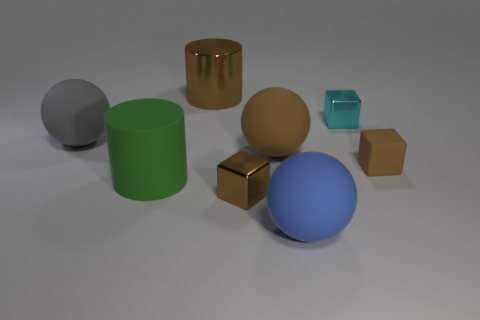There is a large brown matte object; does it have the same shape as the shiny object behind the cyan block?
Your answer should be compact. No. How many things are big brown rubber balls behind the green cylinder or matte objects in front of the big gray thing?
Ensure brevity in your answer.  4. What shape is the large object that is the same color as the metal cylinder?
Your answer should be compact. Sphere. There is a brown matte thing that is to the left of the tiny cyan shiny thing; what shape is it?
Ensure brevity in your answer.  Sphere. Is the shape of the large brown thing that is on the right side of the big shiny cylinder the same as  the tiny rubber object?
Make the answer very short. No. How many objects are matte things that are right of the big metal cylinder or brown cylinders?
Provide a short and direct response. 4. There is a matte thing that is the same shape as the large brown shiny thing; what is its color?
Keep it short and to the point. Green. Are there any other things that have the same color as the big matte cylinder?
Ensure brevity in your answer.  No. What size is the ball in front of the rubber block?
Make the answer very short. Large. There is a metallic cylinder; does it have the same color as the small rubber block behind the tiny brown shiny block?
Keep it short and to the point. Yes. 